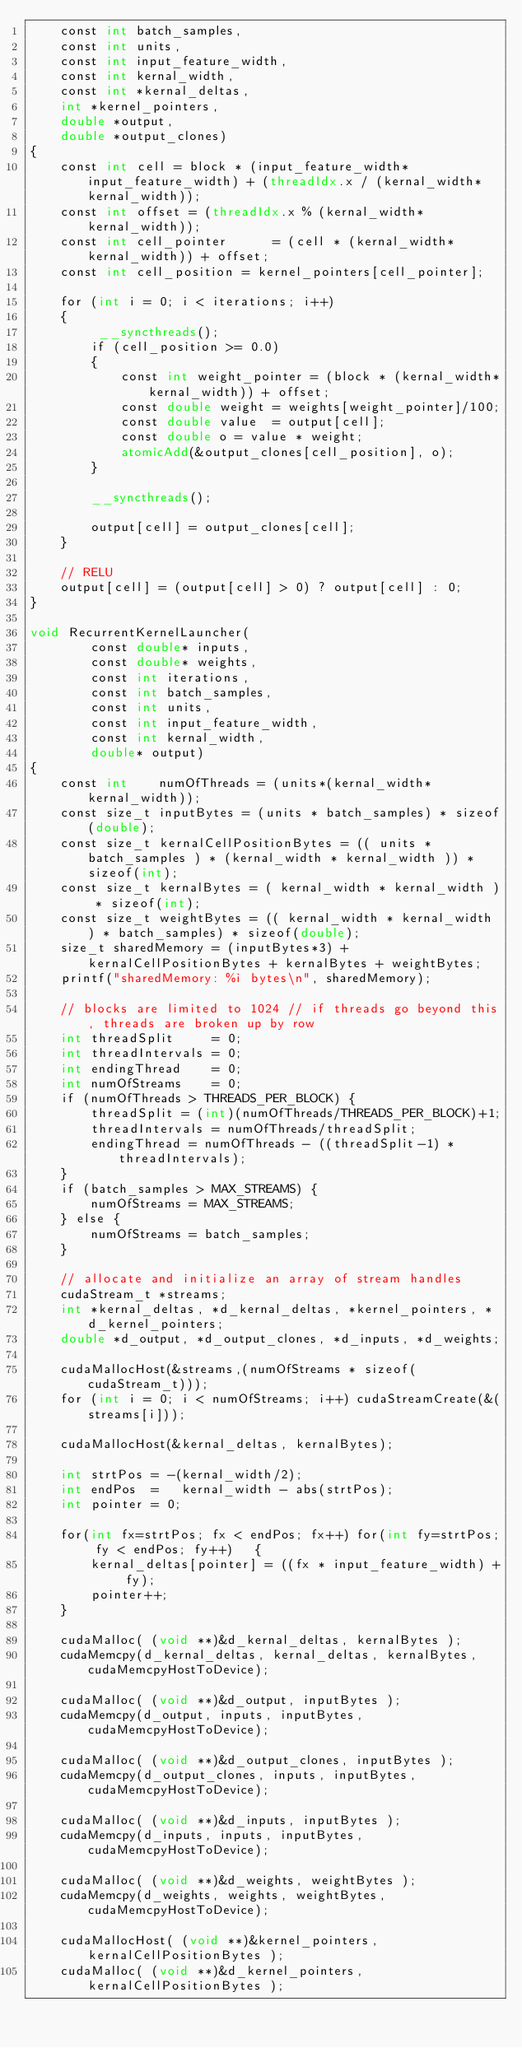Convert code to text. <code><loc_0><loc_0><loc_500><loc_500><_Cuda_>    const int batch_samples, 
    const int units, 
    const int input_feature_width,
    const int kernal_width,
    const int *kernal_deltas,
    int *kernel_pointers,
    double *output,
    double *output_clones) 
{
    const int cell = block * (input_feature_width*input_feature_width) + (threadIdx.x / (kernal_width*kernal_width)); 
    const int offset = (threadIdx.x % (kernal_width*kernal_width));
    const int cell_pointer      = (cell * (kernal_width*kernal_width)) + offset;
    const int cell_position = kernel_pointers[cell_pointer];

    for (int i = 0; i < iterations; i++)
    {
         __syncthreads();
        if (cell_position >= 0.0)
        {   
            const int weight_pointer = (block * (kernal_width*kernal_width)) + offset; 
            const double weight = weights[weight_pointer]/100;
            const double value  = output[cell];
            const double o = value * weight;
            atomicAdd(&output_clones[cell_position], o);
        }

        __syncthreads();

        output[cell] = output_clones[cell];
    }

    // RELU
    output[cell] = (output[cell] > 0) ? output[cell] : 0;
}

void RecurrentKernelLauncher(
        const double* inputs, 
        const double* weights,
        const int iterations,
        const int batch_samples, 
        const int units, 
        const int input_feature_width,
        const int kernal_width,
        double* output) 
{
    const int    numOfThreads = (units*(kernal_width*kernal_width));
    const size_t inputBytes = (units * batch_samples) * sizeof(double);
    const size_t kernalCellPositionBytes = (( units * batch_samples ) * (kernal_width * kernal_width )) * sizeof(int);
    const size_t kernalBytes = ( kernal_width * kernal_width ) * sizeof(int);
    const size_t weightBytes = (( kernal_width * kernal_width ) * batch_samples) * sizeof(double);
    size_t sharedMemory = (inputBytes*3) + kernalCellPositionBytes + kernalBytes + weightBytes;
    printf("sharedMemory: %i bytes\n", sharedMemory);

    // blocks are limited to 1024 // if threads go beyond this, threads are broken up by row
    int threadSplit     = 0;
    int threadIntervals = 0;
    int endingThread    = 0;
    int numOfStreams    = 0;
    if (numOfThreads > THREADS_PER_BLOCK) {
        threadSplit = (int)(numOfThreads/THREADS_PER_BLOCK)+1;
        threadIntervals = numOfThreads/threadSplit;
        endingThread = numOfThreads - ((threadSplit-1) * threadIntervals);
    }
    if (batch_samples > MAX_STREAMS) {
        numOfStreams = MAX_STREAMS;
    } else {
        numOfStreams = batch_samples;
    }

    // allocate and initialize an array of stream handles
    cudaStream_t *streams;
    int *kernal_deltas, *d_kernal_deltas, *kernel_pointers, *d_kernel_pointers; 
    double *d_output, *d_output_clones, *d_inputs, *d_weights;

    cudaMallocHost(&streams,(numOfStreams * sizeof(cudaStream_t)));
    for (int i = 0; i < numOfStreams; i++) cudaStreamCreate(&(streams[i]));

    cudaMallocHost(&kernal_deltas, kernalBytes);

    int strtPos = -(kernal_width/2);
    int endPos  =   kernal_width - abs(strtPos);
    int pointer = 0;

    for(int fx=strtPos; fx < endPos; fx++) for(int fy=strtPos; fy < endPos; fy++)   {
        kernal_deltas[pointer] = ((fx * input_feature_width) + fy);
        pointer++;
    }

    cudaMalloc( (void **)&d_kernal_deltas, kernalBytes );
    cudaMemcpy(d_kernal_deltas, kernal_deltas, kernalBytes, cudaMemcpyHostToDevice);

    cudaMalloc( (void **)&d_output, inputBytes );
    cudaMemcpy(d_output, inputs, inputBytes, cudaMemcpyHostToDevice);

    cudaMalloc( (void **)&d_output_clones, inputBytes );
    cudaMemcpy(d_output_clones, inputs, inputBytes, cudaMemcpyHostToDevice);

    cudaMalloc( (void **)&d_inputs, inputBytes );
    cudaMemcpy(d_inputs, inputs, inputBytes, cudaMemcpyHostToDevice);

    cudaMalloc( (void **)&d_weights, weightBytes );
    cudaMemcpy(d_weights, weights, weightBytes, cudaMemcpyHostToDevice);

    cudaMallocHost( (void **)&kernel_pointers, kernalCellPositionBytes );
    cudaMalloc( (void **)&d_kernel_pointers, kernalCellPositionBytes );</code> 